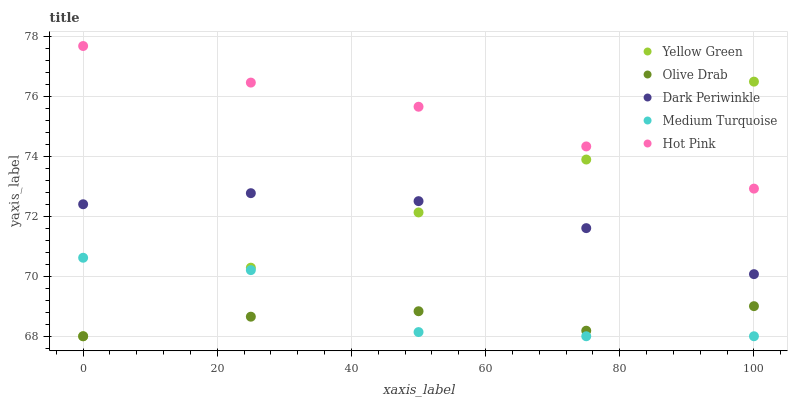Does Olive Drab have the minimum area under the curve?
Answer yes or no. Yes. Does Hot Pink have the maximum area under the curve?
Answer yes or no. Yes. Does Yellow Green have the minimum area under the curve?
Answer yes or no. No. Does Yellow Green have the maximum area under the curve?
Answer yes or no. No. Is Hot Pink the smoothest?
Answer yes or no. Yes. Is Medium Turquoise the roughest?
Answer yes or no. Yes. Is Yellow Green the smoothest?
Answer yes or no. No. Is Yellow Green the roughest?
Answer yes or no. No. Does Medium Turquoise have the lowest value?
Answer yes or no. Yes. Does Hot Pink have the lowest value?
Answer yes or no. No. Does Hot Pink have the highest value?
Answer yes or no. Yes. Does Yellow Green have the highest value?
Answer yes or no. No. Is Olive Drab less than Hot Pink?
Answer yes or no. Yes. Is Hot Pink greater than Medium Turquoise?
Answer yes or no. Yes. Does Medium Turquoise intersect Yellow Green?
Answer yes or no. Yes. Is Medium Turquoise less than Yellow Green?
Answer yes or no. No. Is Medium Turquoise greater than Yellow Green?
Answer yes or no. No. Does Olive Drab intersect Hot Pink?
Answer yes or no. No. 